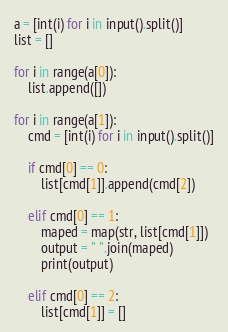<code> <loc_0><loc_0><loc_500><loc_500><_Python_>a = [int(i) for i in input().split()]
list = []

for i in range(a[0]):
    list.append([])

for i in range(a[1]):
    cmd = [int(i) for i in input().split()]

    if cmd[0] == 0:
        list[cmd[1]].append(cmd[2])

    elif cmd[0] == 1:
        maped = map(str, list[cmd[1]])
        output = " ".join(maped)
        print(output)

    elif cmd[0] == 2:
        list[cmd[1]] = []

</code> 